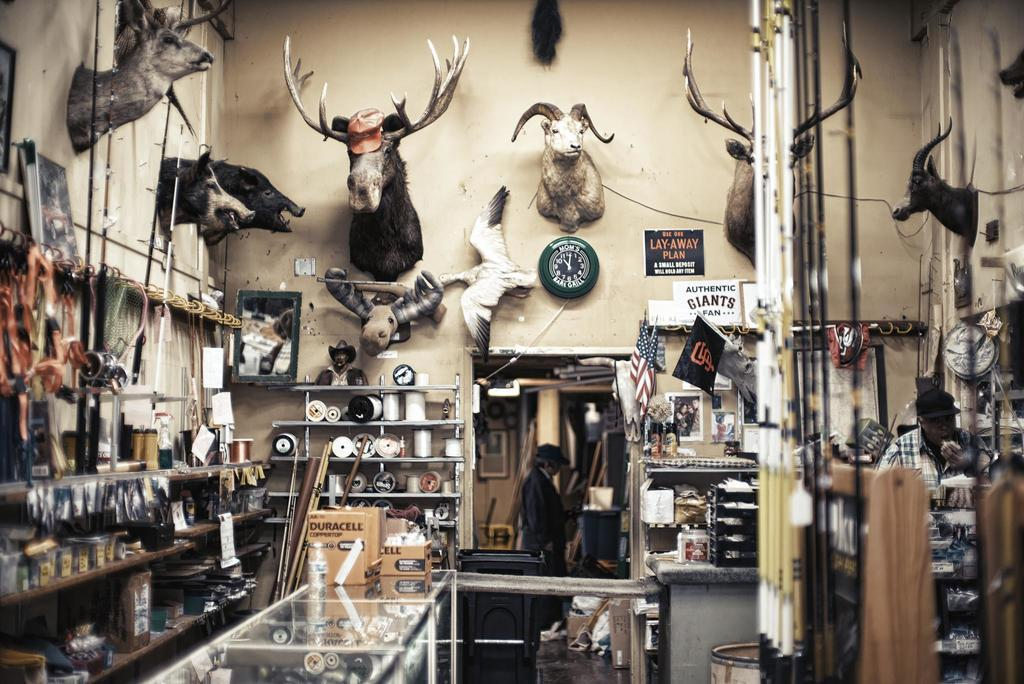<image>
Summarize the visual content of the image. A hunting shop features a sign that says AUTHENTIC GIANTS FAN. 